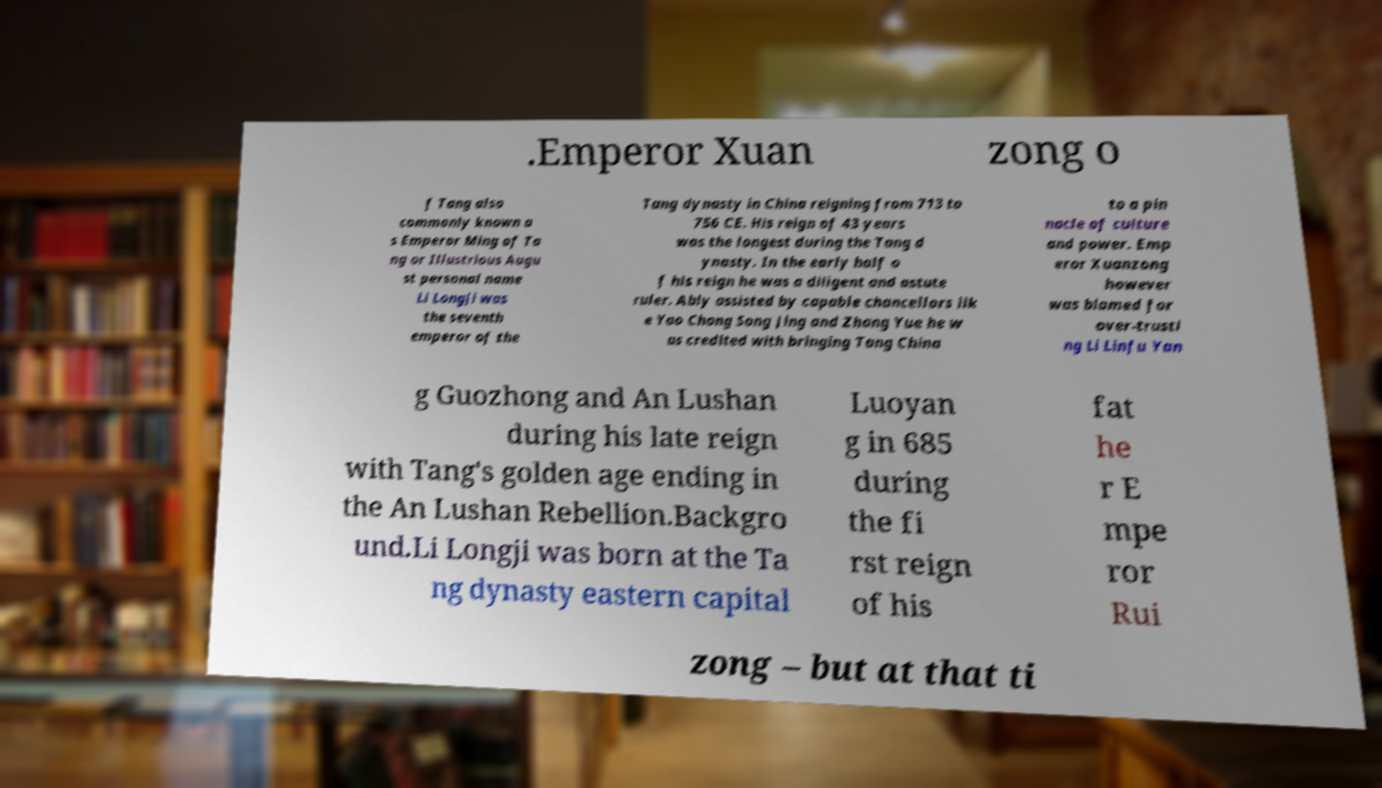Could you assist in decoding the text presented in this image and type it out clearly? .Emperor Xuan zong o f Tang also commonly known a s Emperor Ming of Ta ng or Illustrious Augu st personal name Li Longji was the seventh emperor of the Tang dynasty in China reigning from 713 to 756 CE. His reign of 43 years was the longest during the Tang d ynasty. In the early half o f his reign he was a diligent and astute ruler. Ably assisted by capable chancellors lik e Yao Chong Song Jing and Zhang Yue he w as credited with bringing Tang China to a pin nacle of culture and power. Emp eror Xuanzong however was blamed for over-trusti ng Li Linfu Yan g Guozhong and An Lushan during his late reign with Tang's golden age ending in the An Lushan Rebellion.Backgro und.Li Longji was born at the Ta ng dynasty eastern capital Luoyan g in 685 during the fi rst reign of his fat he r E mpe ror Rui zong – but at that ti 